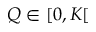Convert formula to latex. <formula><loc_0><loc_0><loc_500><loc_500>Q \in [ 0 , K [</formula> 